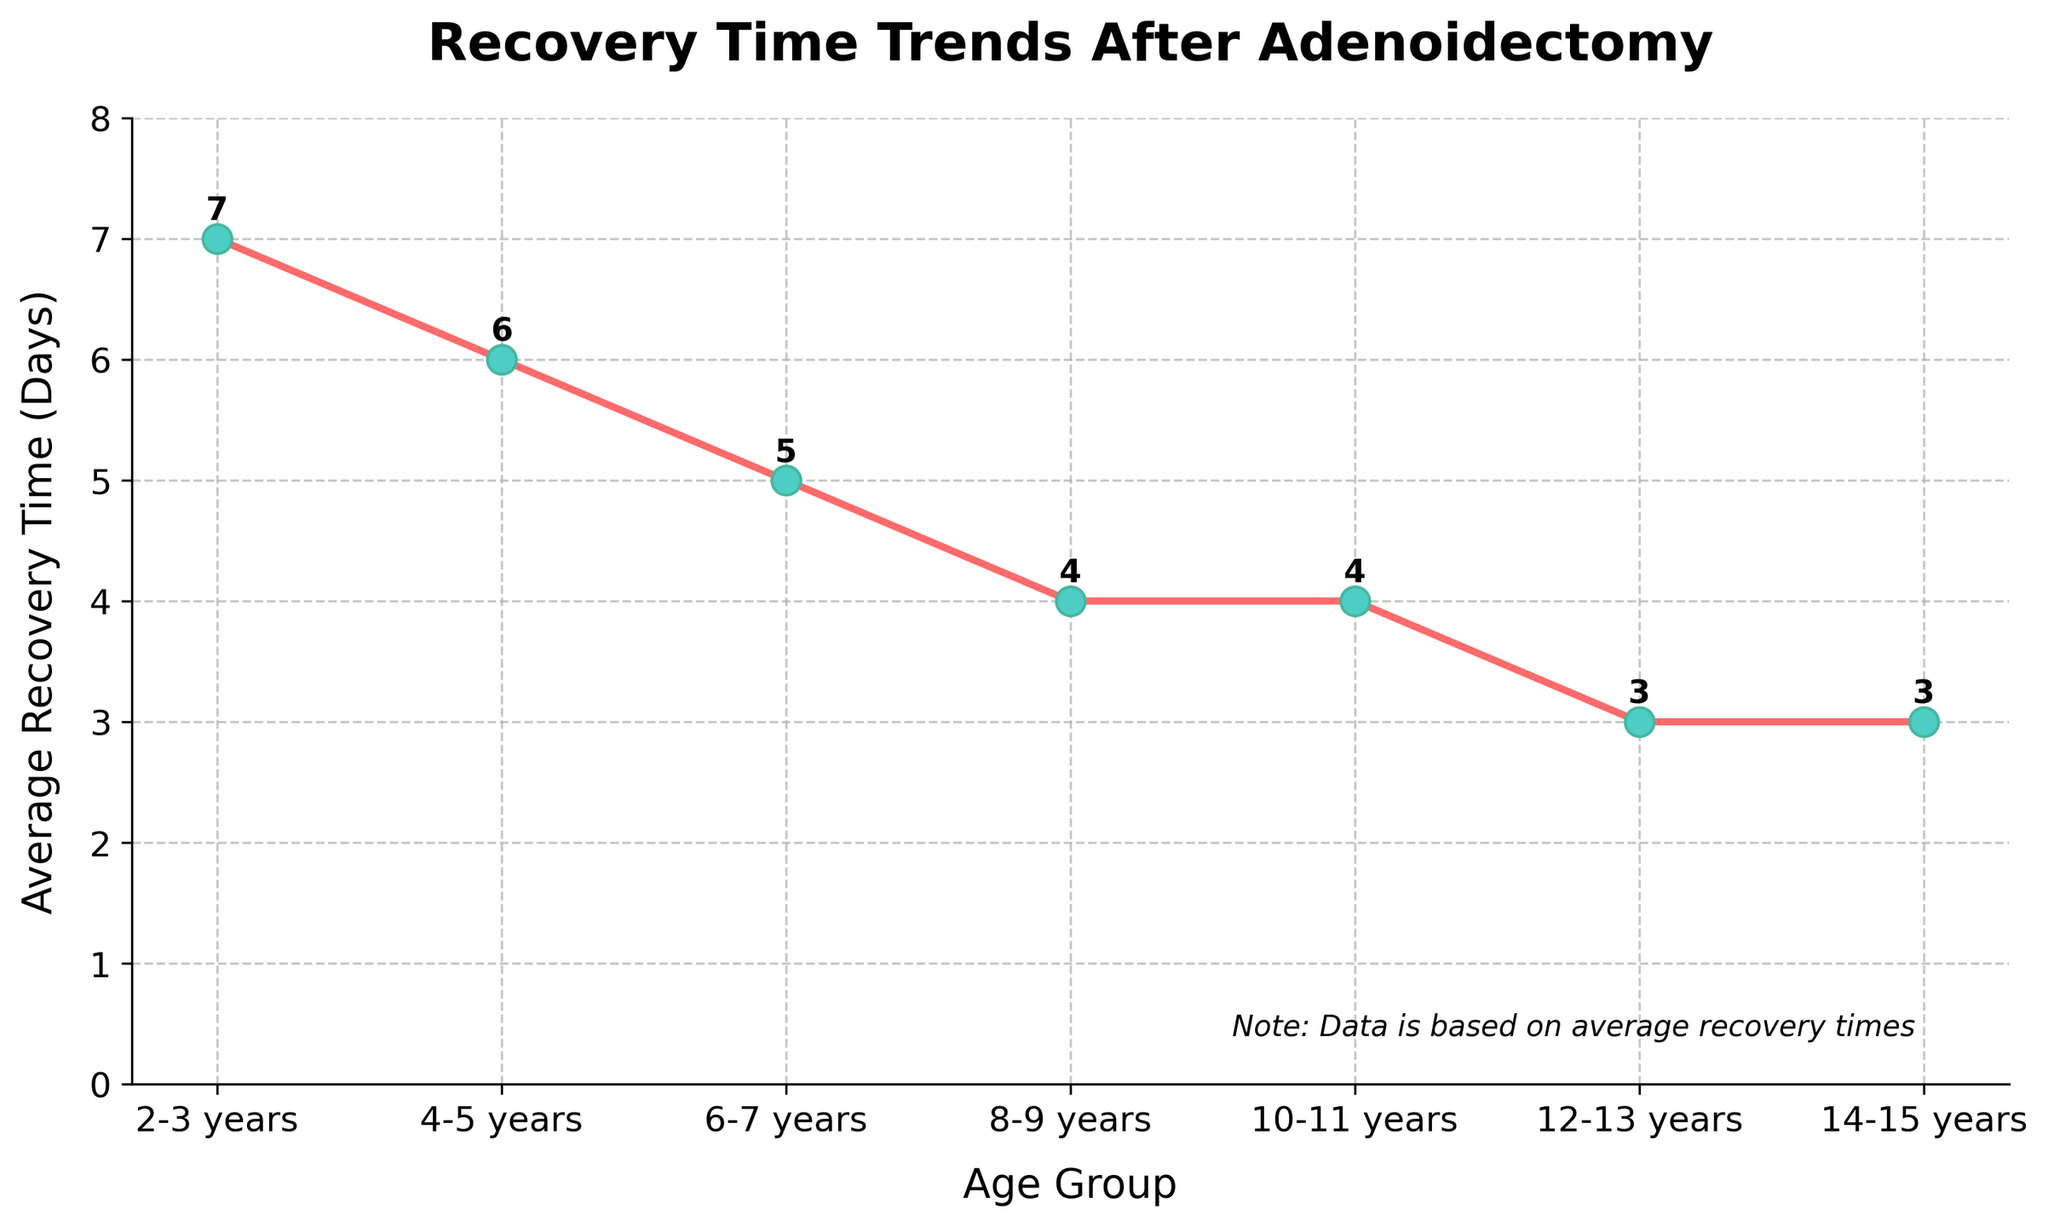What's the average recovery time for age groups 4-5 years and 6-7 years? First, we identify the recovery times for these age groups: 6 days and 5 days. Sum them: 6 + 5 = 11. Divide by the number of groups (2): 11 / 2 = 5.5.
Answer: 5.5 Which age group has the longest average recovery time? From the figure, we see that the age group 2-3 years has the highest recovery time at 7 days.
Answer: 2-3 years By how many days does the recovery time decrease from the 2-3 years group to the 12-13 years group? The recovery time for 2-3 years is 7 days and for 12-13 years it is 3 days. The difference is 7 - 3 = 4.
Answer: 4 Which age group has the shortest recovery time? The figure shows that both age groups 12-13 years and 14-15 years have the lowest recovery time of 3 days.
Answer: 12-13 years and 14-15 years What is the total recovery time sum of all age groups? Summing all the recovery times: 7 + 6 + 5 + 4 + 4 + 3 + 3 = 32.
Answer: 32 Which age groups have the same average recovery time? The groups 8-9 years and 10-11 years both have a recovery time of 4 days. The groups 12-13 years and 14-15 years both have a recovery time of 3 days.
Answer: 8-9 years & 10-11 years, 12-13 years & 14-15 years Between which consecutive age groups is the largest decrease in recovery time observed? Compare the differences between consecutive age groups: (7 to 6), (6 to 5), (5 to 4), (4 to 4), and (4 to 3). The largest decrease is from 2-3 years (7 days) to 4-5 years (6 days): 7 - 6 = 1.
Answer: 2-3 years to 4-5 years What is the combined recovery time for age groups 2-3 years, 4-5 years, and 6-7 years? Adding recovery times for 2-3 years (7 days), 4-5 years (6 days), and 6-7 years (5 days): 7 + 6 + 5 = 18 days.
Answer: 18 days How many days lower is the recovery time for 14-15 years compared to 2-3 years? The recovery time for 2-3 years is 7 days, and for 14-15 years it is 3 days. The difference is 7 - 3 = 4 days.
Answer: 4 days What is the range of recovery times across all age groups? The highest recovery time is 7 days (2-3 years) and the lowest is 3 days (12-13 years & 14-15 years). The range is 7 - 3 = 4 days.
Answer: 4 days 